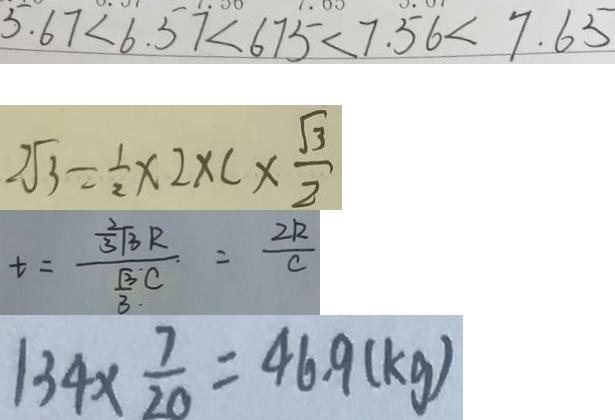<formula> <loc_0><loc_0><loc_500><loc_500>5 . 6 7 < 6 . 5 7 < 6 7 5 < 7 . 5 6 < 7 . 6 5 
 2 \sqrt { 3 } = \frac { 1 } { 2 } \times 2 \times C \times \frac { \sqrt { 3 } } { 2 } 
 t = \frac { \frac { 2 } { 3 } \sqrt { 3 } R } { \frac { \sqrt { 3 } } { 3 . } C } = \frac { 2 R } { c } 
 1 3 4 \times \frac { 7 } { 2 0 } = 4 6 . 9 ( k g )</formula> 